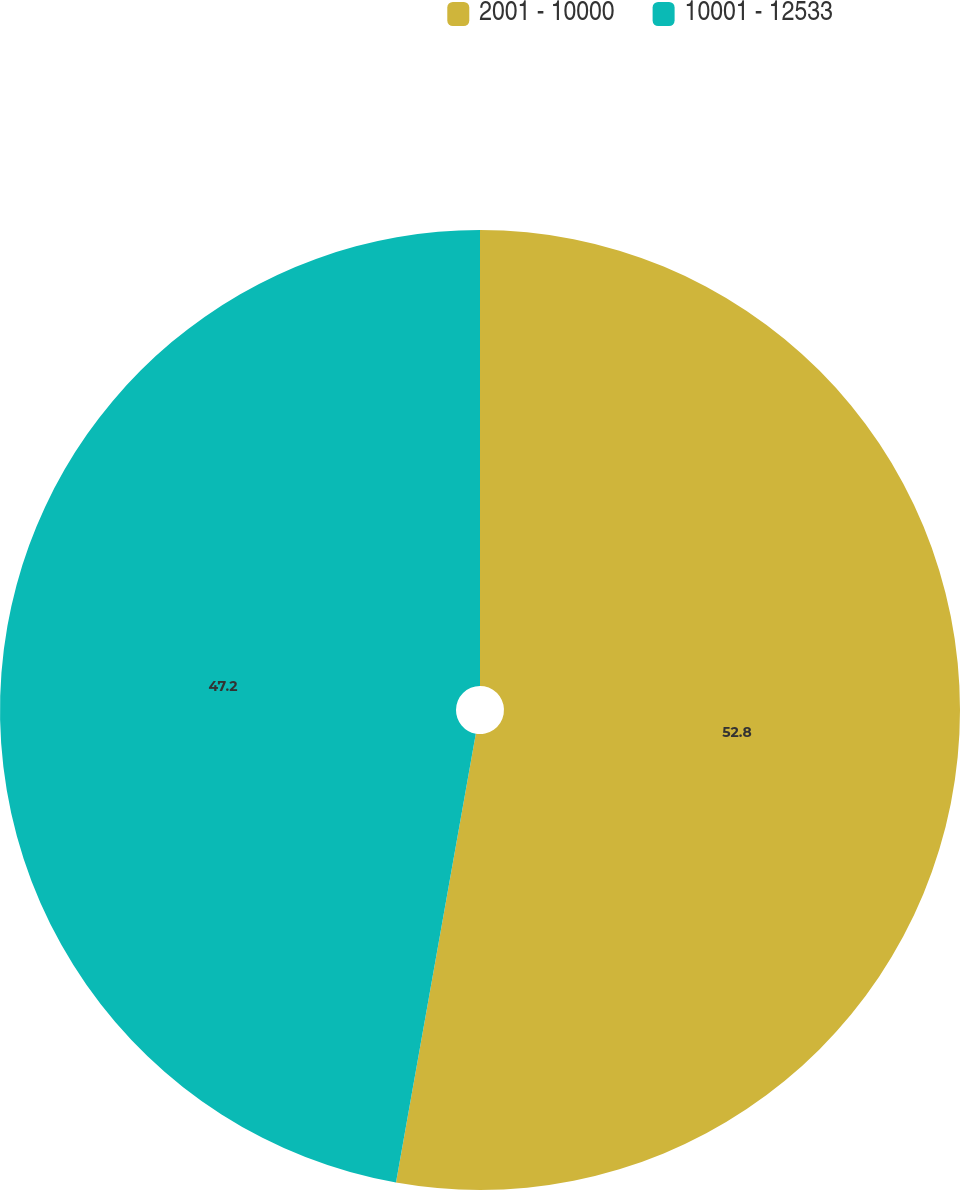<chart> <loc_0><loc_0><loc_500><loc_500><pie_chart><fcel>2001 - 10000<fcel>10001 - 12533<nl><fcel>52.8%<fcel>47.2%<nl></chart> 